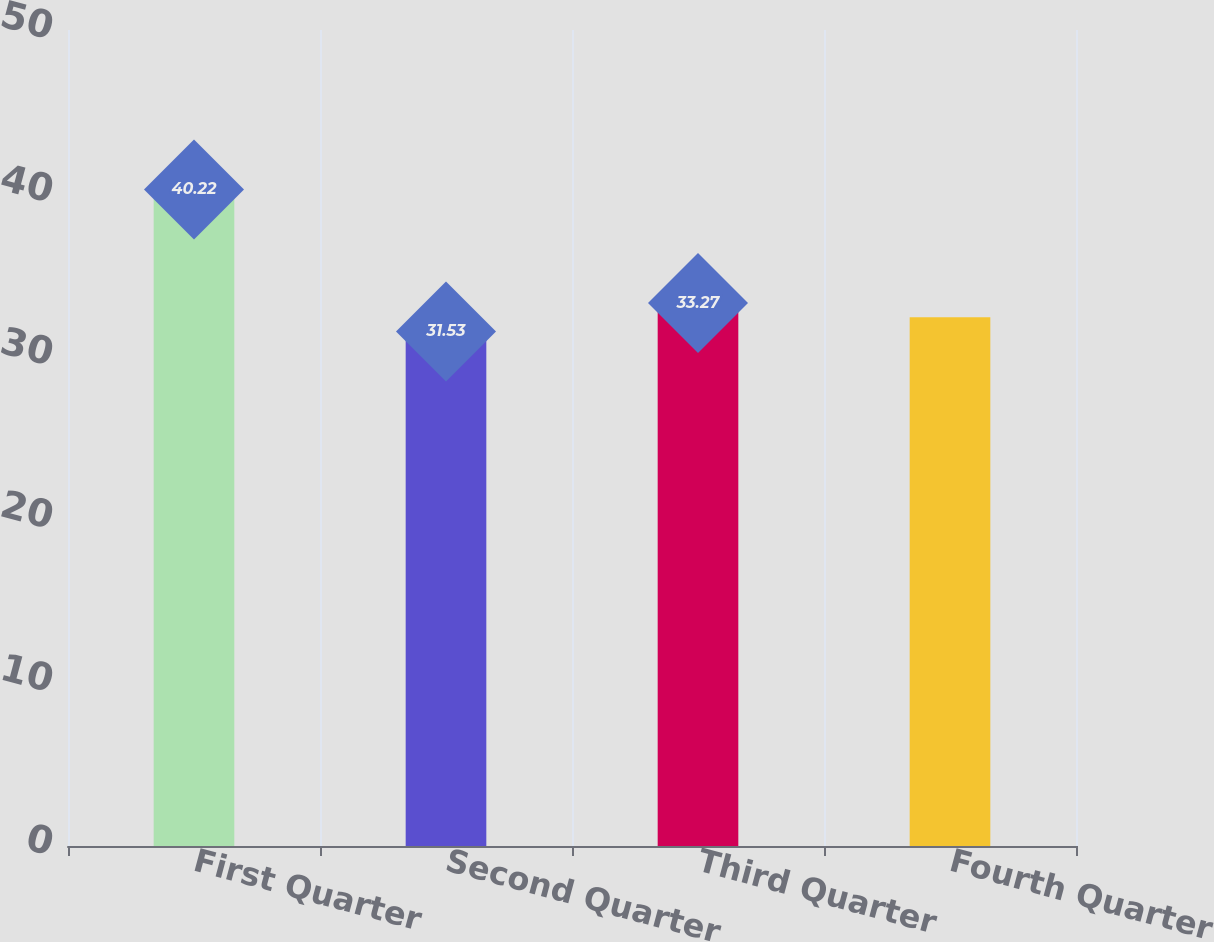Convert chart. <chart><loc_0><loc_0><loc_500><loc_500><bar_chart><fcel>First Quarter<fcel>Second Quarter<fcel>Third Quarter<fcel>Fourth Quarter<nl><fcel>40.22<fcel>31.53<fcel>33.27<fcel>32.4<nl></chart> 